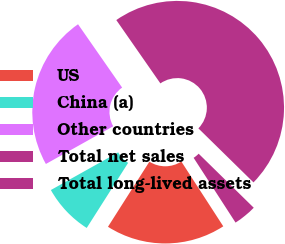<chart> <loc_0><loc_0><loc_500><loc_500><pie_chart><fcel>US<fcel>China (a)<fcel>Other countries<fcel>Total net sales<fcel>Total long-lived assets<nl><fcel>18.16%<fcel>7.86%<fcel>23.44%<fcel>47.02%<fcel>3.51%<nl></chart> 